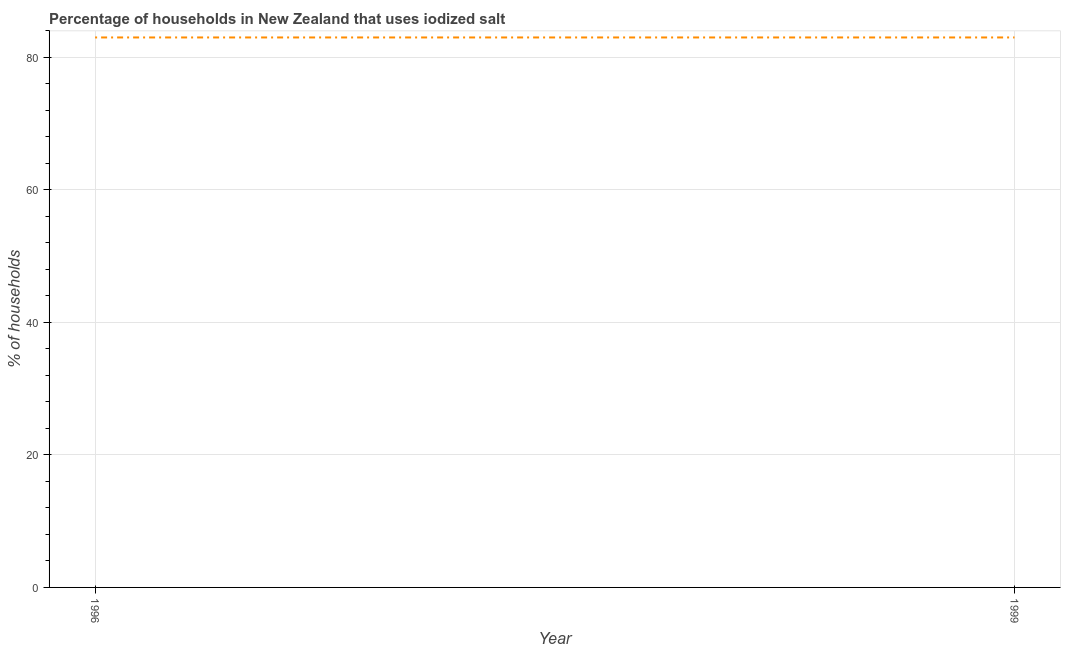What is the percentage of households where iodized salt is consumed in 1999?
Keep it short and to the point. 83. Across all years, what is the maximum percentage of households where iodized salt is consumed?
Keep it short and to the point. 83. Across all years, what is the minimum percentage of households where iodized salt is consumed?
Your response must be concise. 83. What is the sum of the percentage of households where iodized salt is consumed?
Give a very brief answer. 166. What is the average percentage of households where iodized salt is consumed per year?
Keep it short and to the point. 83. What is the median percentage of households where iodized salt is consumed?
Offer a terse response. 83. What is the ratio of the percentage of households where iodized salt is consumed in 1996 to that in 1999?
Offer a terse response. 1. Does the percentage of households where iodized salt is consumed monotonically increase over the years?
Offer a terse response. No. How many lines are there?
Give a very brief answer. 1. Are the values on the major ticks of Y-axis written in scientific E-notation?
Offer a terse response. No. What is the title of the graph?
Offer a very short reply. Percentage of households in New Zealand that uses iodized salt. What is the label or title of the Y-axis?
Provide a short and direct response. % of households. What is the % of households in 1996?
Your response must be concise. 83. What is the % of households of 1999?
Your answer should be compact. 83. What is the difference between the % of households in 1996 and 1999?
Give a very brief answer. 0. 